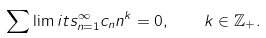Convert formula to latex. <formula><loc_0><loc_0><loc_500><loc_500>\sum \lim i t s _ { n = 1 } ^ { \infty } c _ { n } n ^ { k } = 0 , \quad k \in \mathbb { Z } _ { + } .</formula> 